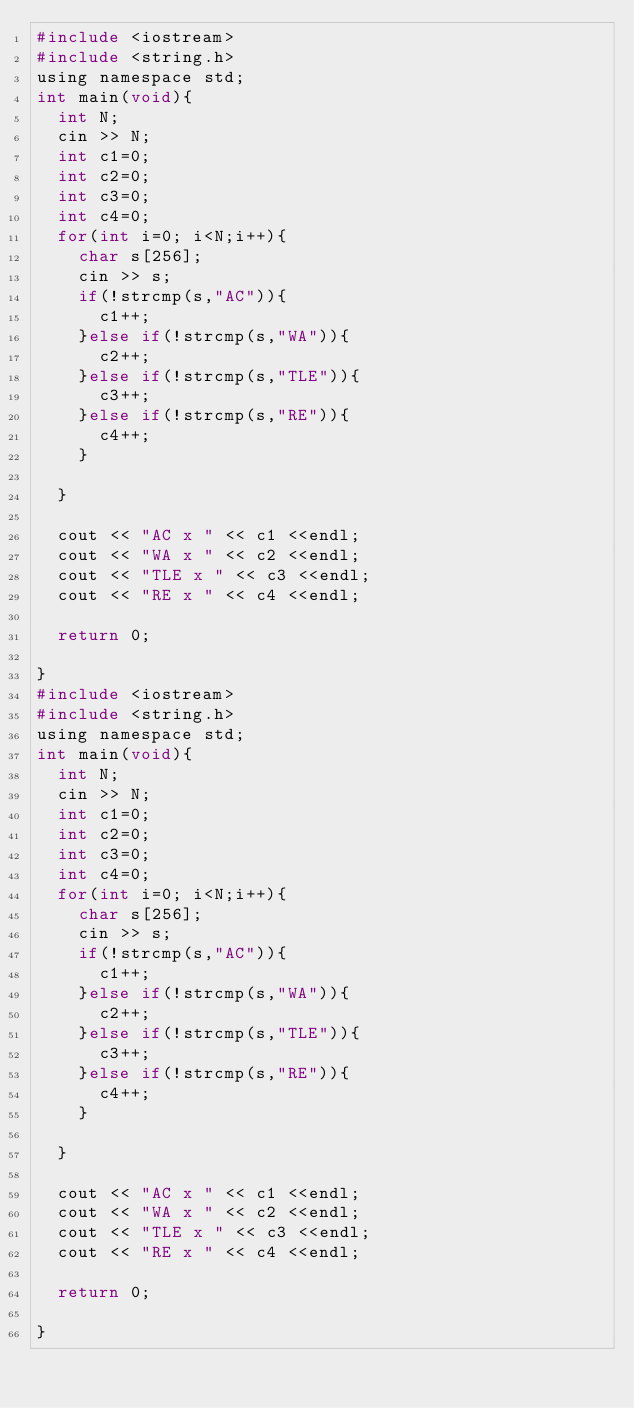<code> <loc_0><loc_0><loc_500><loc_500><_C_>#include <iostream>
#include <string.h>
using namespace std;
int main(void){
	int N;
	cin >> N;
	int c1=0;
	int c2=0;
	int c3=0;
	int c4=0;
	for(int i=0; i<N;i++){
		char s[256];
		cin >> s;
		if(!strcmp(s,"AC")){
			c1++;
		}else if(!strcmp(s,"WA")){
			c2++;
		}else if(!strcmp(s,"TLE")){
			c3++;
		}else if(!strcmp(s,"RE")){
			c4++;
		}
		
	}
	
	cout << "AC x " << c1 <<endl;
	cout << "WA x " << c2 <<endl;
	cout << "TLE x " << c3 <<endl;
	cout << "RE x " << c4 <<endl;
	
	return 0;
 
}
#include <iostream>
#include <string.h>
using namespace std;
int main(void){
	int N;
	cin >> N;
	int c1=0;
	int c2=0;
	int c3=0;
	int c4=0;
	for(int i=0; i<N;i++){
		char s[256];
		cin >> s;
		if(!strcmp(s,"AC")){
			c1++;
		}else if(!strcmp(s,"WA")){
			c2++;
		}else if(!strcmp(s,"TLE")){
			c3++;
		}else if(!strcmp(s,"RE")){
			c4++;
		}
		
	}
	
	cout << "AC x " << c1 <<endl;
	cout << "WA x " << c2 <<endl;
	cout << "TLE x " << c3 <<endl;
	cout << "RE x " << c4 <<endl;
	
	return 0;

}</code> 